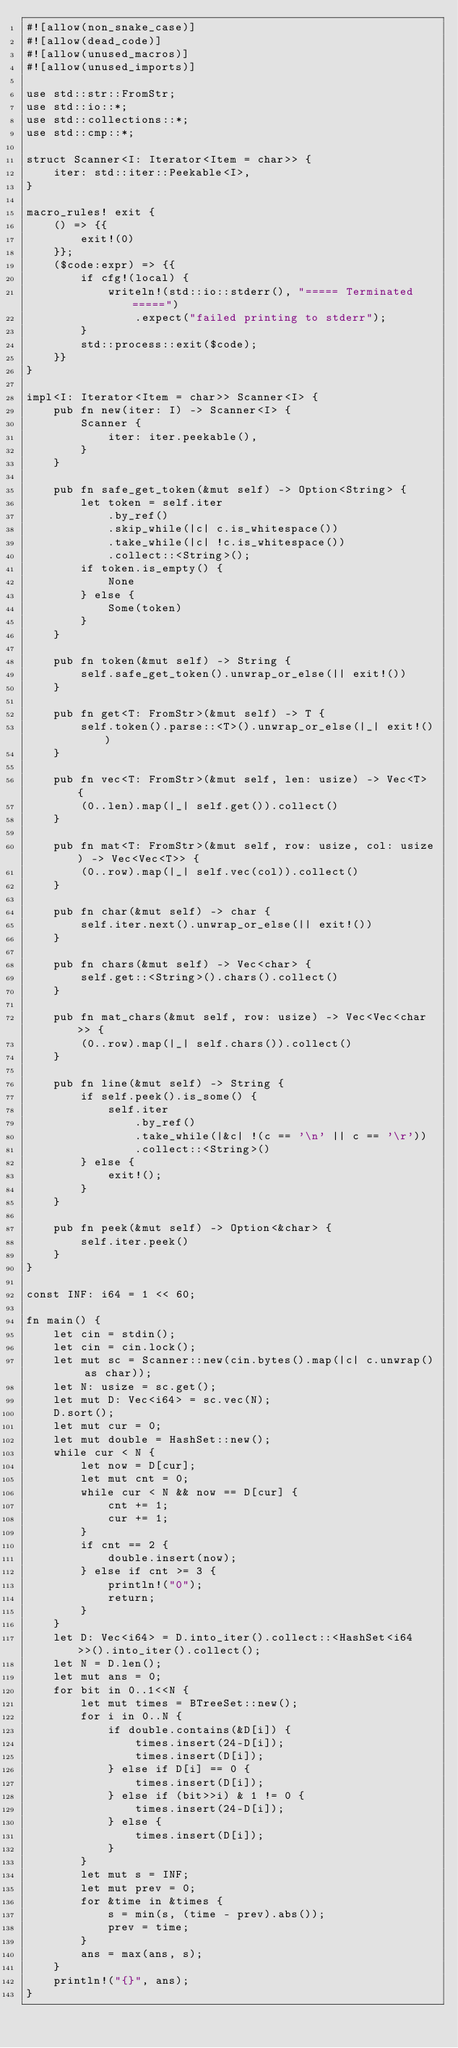Convert code to text. <code><loc_0><loc_0><loc_500><loc_500><_Rust_>#![allow(non_snake_case)]
#![allow(dead_code)]
#![allow(unused_macros)]
#![allow(unused_imports)]

use std::str::FromStr;
use std::io::*;
use std::collections::*;
use std::cmp::*;

struct Scanner<I: Iterator<Item = char>> {
    iter: std::iter::Peekable<I>,
}

macro_rules! exit {
    () => {{
        exit!(0)
    }};
    ($code:expr) => {{
        if cfg!(local) {
            writeln!(std::io::stderr(), "===== Terminated =====")
                .expect("failed printing to stderr");
        }
        std::process::exit($code);
    }}
}

impl<I: Iterator<Item = char>> Scanner<I> {
    pub fn new(iter: I) -> Scanner<I> {
        Scanner {
            iter: iter.peekable(),
        }
    }

    pub fn safe_get_token(&mut self) -> Option<String> {
        let token = self.iter
            .by_ref()
            .skip_while(|c| c.is_whitespace())
            .take_while(|c| !c.is_whitespace())
            .collect::<String>();
        if token.is_empty() {
            None
        } else {
            Some(token)
        }
    }

    pub fn token(&mut self) -> String {
        self.safe_get_token().unwrap_or_else(|| exit!())
    }

    pub fn get<T: FromStr>(&mut self) -> T {
        self.token().parse::<T>().unwrap_or_else(|_| exit!())
    }

    pub fn vec<T: FromStr>(&mut self, len: usize) -> Vec<T> {
        (0..len).map(|_| self.get()).collect()
    }

    pub fn mat<T: FromStr>(&mut self, row: usize, col: usize) -> Vec<Vec<T>> {
        (0..row).map(|_| self.vec(col)).collect()
    }

    pub fn char(&mut self) -> char {
        self.iter.next().unwrap_or_else(|| exit!())
    }

    pub fn chars(&mut self) -> Vec<char> {
        self.get::<String>().chars().collect()
    }

    pub fn mat_chars(&mut self, row: usize) -> Vec<Vec<char>> {
        (0..row).map(|_| self.chars()).collect()
    }

    pub fn line(&mut self) -> String {
        if self.peek().is_some() {
            self.iter
                .by_ref()
                .take_while(|&c| !(c == '\n' || c == '\r'))
                .collect::<String>()
        } else {
            exit!();
        }
    }

    pub fn peek(&mut self) -> Option<&char> {
        self.iter.peek()
    }
}

const INF: i64 = 1 << 60;

fn main() {
    let cin = stdin();
    let cin = cin.lock();
    let mut sc = Scanner::new(cin.bytes().map(|c| c.unwrap() as char));
    let N: usize = sc.get();
    let mut D: Vec<i64> = sc.vec(N);
    D.sort();
    let mut cur = 0;
    let mut double = HashSet::new();
    while cur < N {
        let now = D[cur];
        let mut cnt = 0;
        while cur < N && now == D[cur] {
            cnt += 1;
            cur += 1;
        }
        if cnt == 2 {
            double.insert(now);
        } else if cnt >= 3 {
            println!("0");
            return;
        }
    }
    let D: Vec<i64> = D.into_iter().collect::<HashSet<i64>>().into_iter().collect();
    let N = D.len();
    let mut ans = 0;
    for bit in 0..1<<N {
        let mut times = BTreeSet::new();
        for i in 0..N {
            if double.contains(&D[i]) {
                times.insert(24-D[i]);
                times.insert(D[i]);
            } else if D[i] == 0 {
                times.insert(D[i]);
            } else if (bit>>i) & 1 != 0 {
                times.insert(24-D[i]);
            } else {
                times.insert(D[i]);
            }
        }
        let mut s = INF;
        let mut prev = 0;
        for &time in &times {
            s = min(s, (time - prev).abs());
            prev = time;
        }
        ans = max(ans, s);
    }
    println!("{}", ans);
}
</code> 